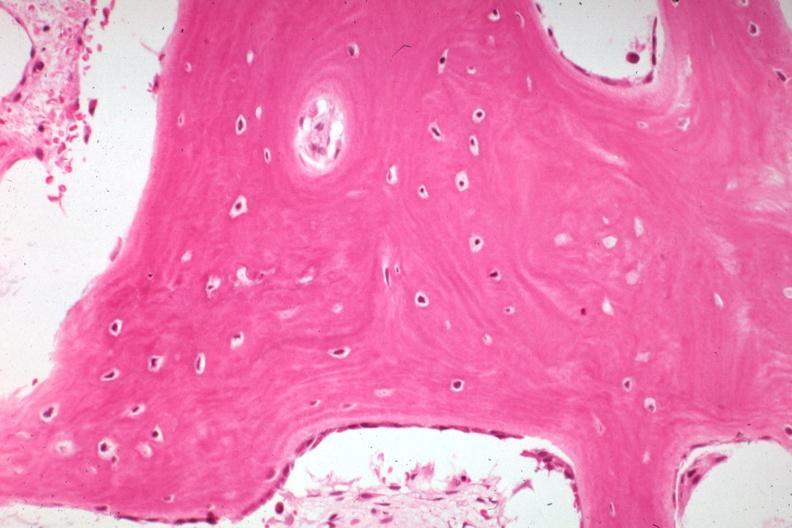what does this image show?
Answer the question using a single word or phrase. High excellent example of bone with remodeling and osteoblasts that now appear inactive 